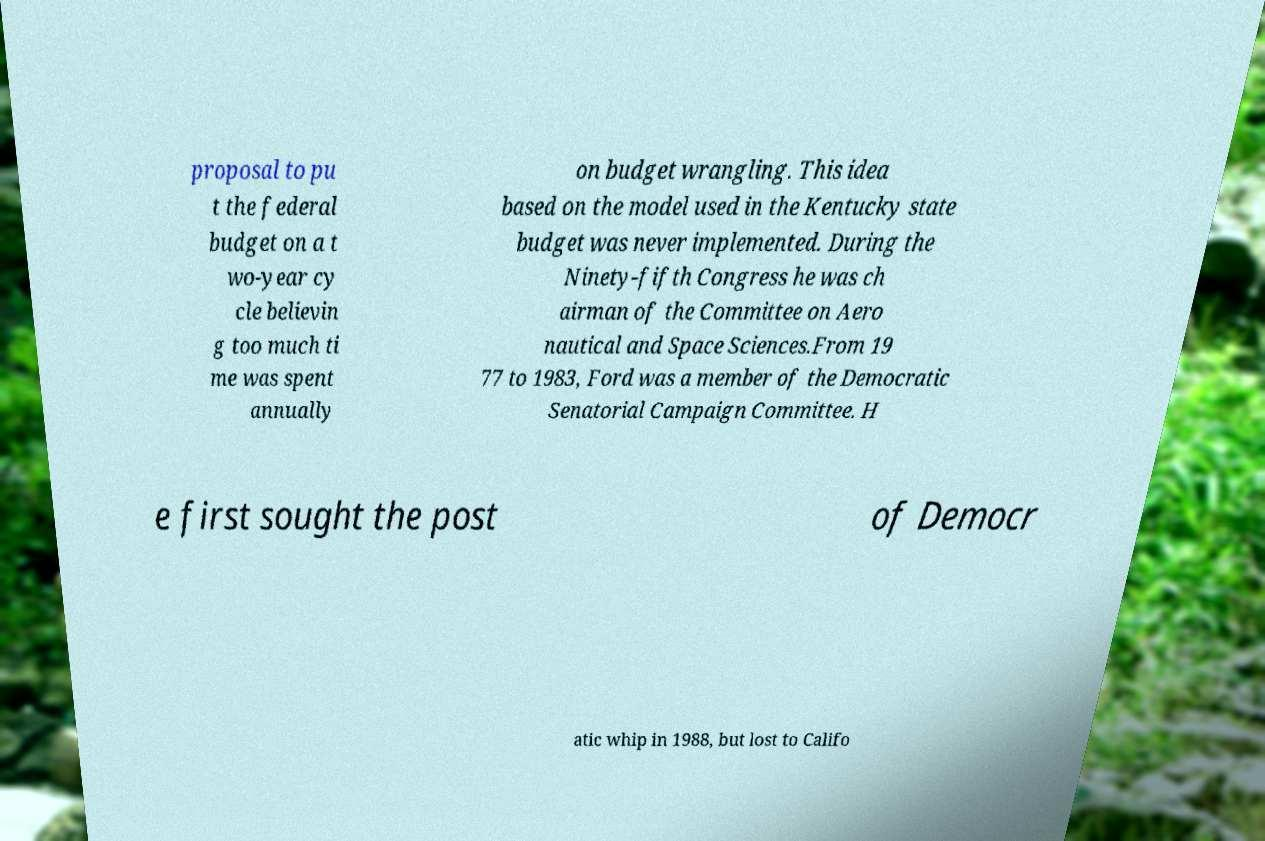Could you assist in decoding the text presented in this image and type it out clearly? proposal to pu t the federal budget on a t wo-year cy cle believin g too much ti me was spent annually on budget wrangling. This idea based on the model used in the Kentucky state budget was never implemented. During the Ninety-fifth Congress he was ch airman of the Committee on Aero nautical and Space Sciences.From 19 77 to 1983, Ford was a member of the Democratic Senatorial Campaign Committee. H e first sought the post of Democr atic whip in 1988, but lost to Califo 